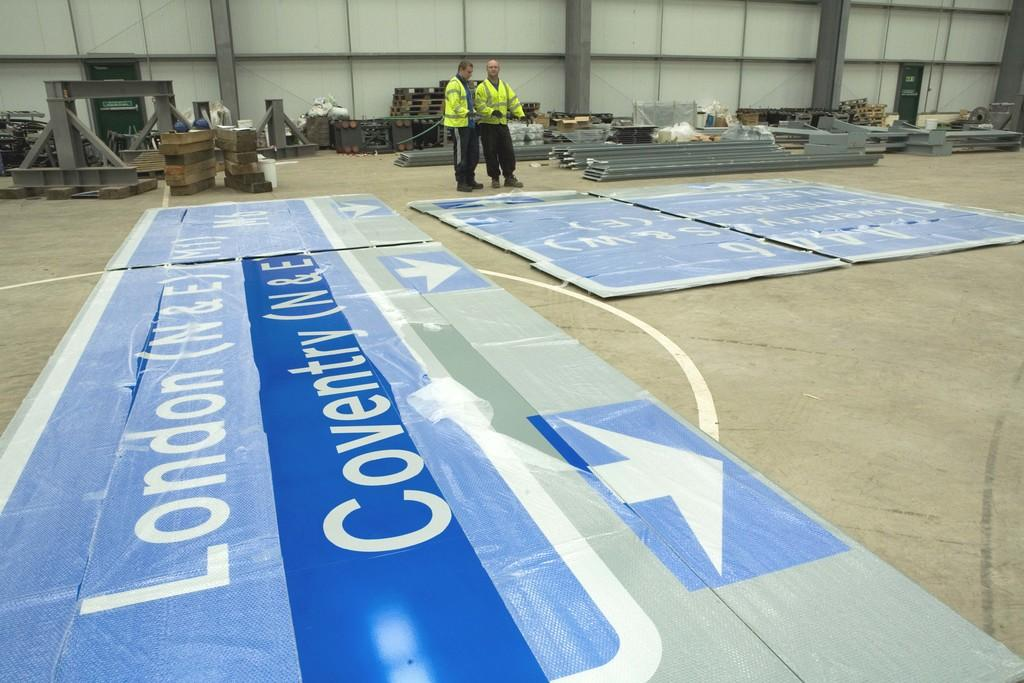How many men are in the image? There are two men standing in the image. What are the men wearing? The men are wearing clothes, gloves, and shoes. What can be seen on the walls in the image? There are posters in the image. What type of surface is visible under the men's feet? There is a floor visible in the image. What material are the objects in the men's hands made of? The objects in the men's hands are made of metal. Can you tell me how many springs are visible in the image? There are no springs visible in the image. What type of steel is used to make the objects in the men's hands? There is no information about the type of steel used to make the objects in the men's hands, as the facts only mention that they are made of metal. 